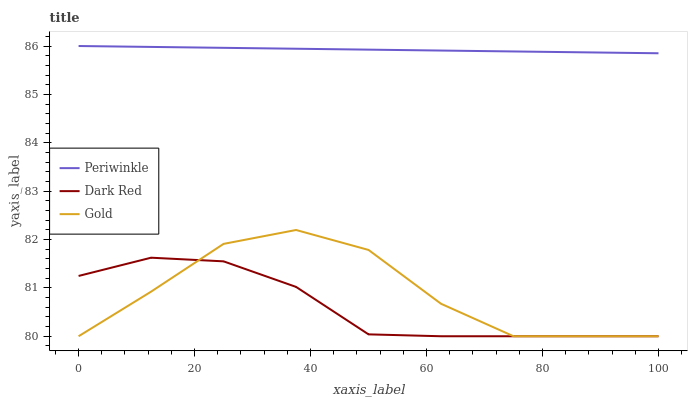Does Dark Red have the minimum area under the curve?
Answer yes or no. Yes. Does Periwinkle have the maximum area under the curve?
Answer yes or no. Yes. Does Gold have the minimum area under the curve?
Answer yes or no. No. Does Gold have the maximum area under the curve?
Answer yes or no. No. Is Periwinkle the smoothest?
Answer yes or no. Yes. Is Gold the roughest?
Answer yes or no. Yes. Is Gold the smoothest?
Answer yes or no. No. Is Periwinkle the roughest?
Answer yes or no. No. Does Dark Red have the lowest value?
Answer yes or no. Yes. Does Periwinkle have the lowest value?
Answer yes or no. No. Does Periwinkle have the highest value?
Answer yes or no. Yes. Does Gold have the highest value?
Answer yes or no. No. Is Dark Red less than Periwinkle?
Answer yes or no. Yes. Is Periwinkle greater than Dark Red?
Answer yes or no. Yes. Does Gold intersect Dark Red?
Answer yes or no. Yes. Is Gold less than Dark Red?
Answer yes or no. No. Is Gold greater than Dark Red?
Answer yes or no. No. Does Dark Red intersect Periwinkle?
Answer yes or no. No. 